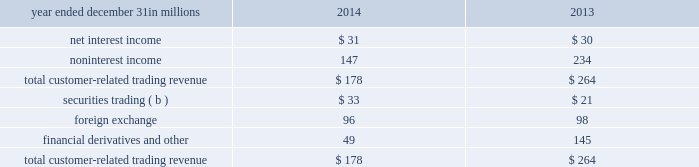These simulations assume that as assets and liabilities mature , they are replaced or repriced at then current market rates .
We also consider forward projections of purchase accounting accretion when forecasting net interest income .
The following graph presents the libor/swap yield curves for the base rate scenario and each of the alternate scenarios one year forward .
Table 51 : alternate interest rate scenarios : one year forward base rates pnc economist market forward slope flattening 2y 3y 5y 10y the fourth quarter 2014 interest sensitivity analyses indicate that our consolidated balance sheet is positioned to benefit from an increase in interest rates and an upward sloping interest rate yield curve .
We believe that we have the deposit funding base and balance sheet flexibility to adjust , where appropriate and permissible , to changing interest rates and market conditions .
Market risk management 2013 customer-related trading we engage in fixed income securities , derivatives and foreign exchange transactions to support our customers 2019 investing and hedging activities .
These transactions , related hedges and the credit valuation adjustment ( cva ) related to our customer derivatives portfolio are marked-to-market daily and reported as customer-related trading activities .
We do not engage in proprietary trading of these products .
We use value-at-risk ( var ) as the primary means to measure and monitor market risk in customer-related trading activities .
We calculate a diversified var at a 95% ( 95 % ) confidence interval .
Var is used to estimate the probability of portfolio losses based on the statistical analysis of historical market risk factors .
A diversified var reflects empirical correlations across different asset classes .
During 2014 , our 95% ( 95 % ) var ranged between $ .8 million and $ 3.9 million , averaging $ 2.1 million .
During 2013 , our 95% ( 95 % ) var ranged between $ 1.7 million and $ 5.5 million , averaging $ 3.5 million .
To help ensure the integrity of the models used to calculate var for each portfolio and enterprise-wide , we use a process known as backtesting .
The backtesting process consists of comparing actual observations of gains or losses against the var levels that were calculated at the close of the prior day .
This assumes that market exposures remain constant throughout the day and that recent historical market variability is a good predictor of future variability .
Our customer-related trading activity includes customer revenue and intraday hedging which helps to reduce losses , and may reduce the number of instances of actual losses exceeding the prior day var measure .
There were two instances during 2014 under our diversified var measure where actual losses exceeded the prior day var measure .
In comparison , there was one such instance during 2013 .
We use a 500 day look back period for backtesting and include customer-related trading revenue .
The following graph shows a comparison of enterprise-wide gains and losses against prior day diversified var for the period indicated .
Table 52 : enterprise 2013 wide gains/losses versus value-at- total customer-related trading revenue was as follows : table 53 : customer-related trading revenue ( a ) year ended december 31 in millions 2014 2013 .
( a ) customer-related trading revenues exclude underwriting fees for both periods presented .
( b ) includes changes in fair value for certain loans accounted for at fair value .
Customer-related trading revenues for 2014 decreased $ 86 million compared with 2013 .
The decrease was primarily due to market interest rate changes impacting credit valuations for customer-related derivatives activities and reduced derivatives client sales revenues , which were partially offset by improved securities and foreign exchange client sales results .
92 the pnc financial services group , inc .
2013 form 10-k .
In millions , what was the total in 2014 and 2013 of net interest income? 
Computations: table_sum(net interest income, none)
Answer: 61.0. These simulations assume that as assets and liabilities mature , they are replaced or repriced at then current market rates .
We also consider forward projections of purchase accounting accretion when forecasting net interest income .
The following graph presents the libor/swap yield curves for the base rate scenario and each of the alternate scenarios one year forward .
Table 51 : alternate interest rate scenarios : one year forward base rates pnc economist market forward slope flattening 2y 3y 5y 10y the fourth quarter 2014 interest sensitivity analyses indicate that our consolidated balance sheet is positioned to benefit from an increase in interest rates and an upward sloping interest rate yield curve .
We believe that we have the deposit funding base and balance sheet flexibility to adjust , where appropriate and permissible , to changing interest rates and market conditions .
Market risk management 2013 customer-related trading we engage in fixed income securities , derivatives and foreign exchange transactions to support our customers 2019 investing and hedging activities .
These transactions , related hedges and the credit valuation adjustment ( cva ) related to our customer derivatives portfolio are marked-to-market daily and reported as customer-related trading activities .
We do not engage in proprietary trading of these products .
We use value-at-risk ( var ) as the primary means to measure and monitor market risk in customer-related trading activities .
We calculate a diversified var at a 95% ( 95 % ) confidence interval .
Var is used to estimate the probability of portfolio losses based on the statistical analysis of historical market risk factors .
A diversified var reflects empirical correlations across different asset classes .
During 2014 , our 95% ( 95 % ) var ranged between $ .8 million and $ 3.9 million , averaging $ 2.1 million .
During 2013 , our 95% ( 95 % ) var ranged between $ 1.7 million and $ 5.5 million , averaging $ 3.5 million .
To help ensure the integrity of the models used to calculate var for each portfolio and enterprise-wide , we use a process known as backtesting .
The backtesting process consists of comparing actual observations of gains or losses against the var levels that were calculated at the close of the prior day .
This assumes that market exposures remain constant throughout the day and that recent historical market variability is a good predictor of future variability .
Our customer-related trading activity includes customer revenue and intraday hedging which helps to reduce losses , and may reduce the number of instances of actual losses exceeding the prior day var measure .
There were two instances during 2014 under our diversified var measure where actual losses exceeded the prior day var measure .
In comparison , there was one such instance during 2013 .
We use a 500 day look back period for backtesting and include customer-related trading revenue .
The following graph shows a comparison of enterprise-wide gains and losses against prior day diversified var for the period indicated .
Table 52 : enterprise 2013 wide gains/losses versus value-at- total customer-related trading revenue was as follows : table 53 : customer-related trading revenue ( a ) year ended december 31 in millions 2014 2013 .
( a ) customer-related trading revenues exclude underwriting fees for both periods presented .
( b ) includes changes in fair value for certain loans accounted for at fair value .
Customer-related trading revenues for 2014 decreased $ 86 million compared with 2013 .
The decrease was primarily due to market interest rate changes impacting credit valuations for customer-related derivatives activities and reduced derivatives client sales revenues , which were partially offset by improved securities and foreign exchange client sales results .
92 the pnc financial services group , inc .
2013 form 10-k .
Between 2014 and 2013 , average 95% ( 95 % ) var decreased by how much in millions?\\n\\n? 
Computations: (3.5 - 2.1)
Answer: 1.4. 